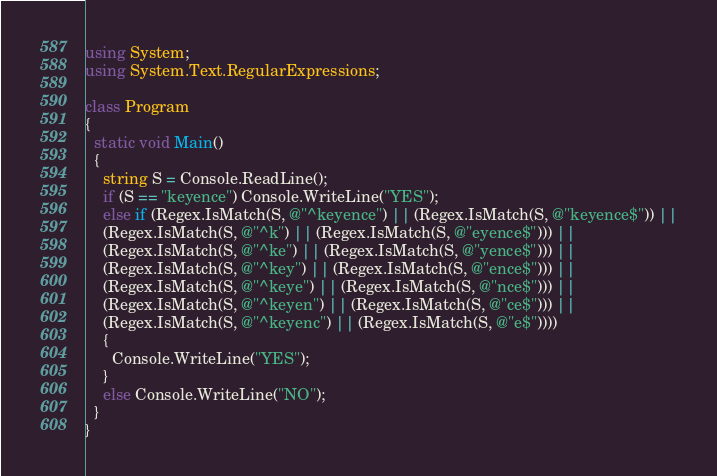Convert code to text. <code><loc_0><loc_0><loc_500><loc_500><_C#_>using System;
using System.Text.RegularExpressions;

class Program
{
  static void Main()
  {
    string S = Console.ReadLine();
    if (S == "keyence") Console.WriteLine("YES");
    else if (Regex.IsMatch(S, @"^keyence") || (Regex.IsMatch(S, @"keyence$")) ||
    (Regex.IsMatch(S, @"^k") || (Regex.IsMatch(S, @"eyence$"))) ||
    (Regex.IsMatch(S, @"^ke") || (Regex.IsMatch(S, @"yence$"))) ||
    (Regex.IsMatch(S, @"^key") || (Regex.IsMatch(S, @"ence$"))) ||
    (Regex.IsMatch(S, @"^keye") || (Regex.IsMatch(S, @"nce$"))) ||
    (Regex.IsMatch(S, @"^keyen") || (Regex.IsMatch(S, @"ce$"))) ||
    (Regex.IsMatch(S, @"^keyenc") || (Regex.IsMatch(S, @"e$"))))
    {
      Console.WriteLine("YES");
    }
    else Console.WriteLine("NO");
  }
}
</code> 